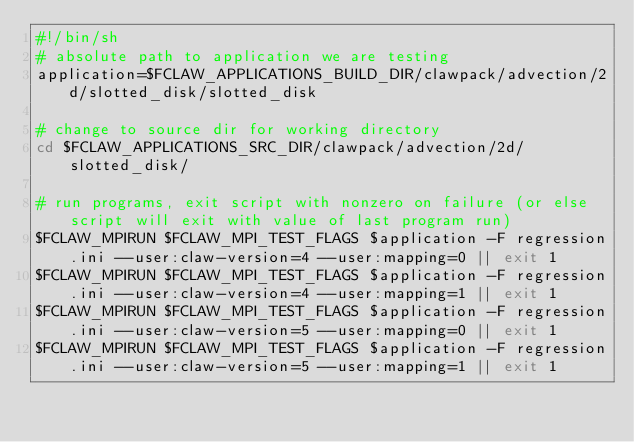Convert code to text. <code><loc_0><loc_0><loc_500><loc_500><_Bash_>#!/bin/sh
# absolute path to application we are testing
application=$FCLAW_APPLICATIONS_BUILD_DIR/clawpack/advection/2d/slotted_disk/slotted_disk

# change to source dir for working directory
cd $FCLAW_APPLICATIONS_SRC_DIR/clawpack/advection/2d/slotted_disk/

# run programs, exit script with nonzero on failure (or else script will exit with value of last program run)
$FCLAW_MPIRUN $FCLAW_MPI_TEST_FLAGS $application -F regression.ini --user:claw-version=4 --user:mapping=0 || exit 1
$FCLAW_MPIRUN $FCLAW_MPI_TEST_FLAGS $application -F regression.ini --user:claw-version=4 --user:mapping=1 || exit 1
$FCLAW_MPIRUN $FCLAW_MPI_TEST_FLAGS $application -F regression.ini --user:claw-version=5 --user:mapping=0 || exit 1
$FCLAW_MPIRUN $FCLAW_MPI_TEST_FLAGS $application -F regression.ini --user:claw-version=5 --user:mapping=1 || exit 1</code> 